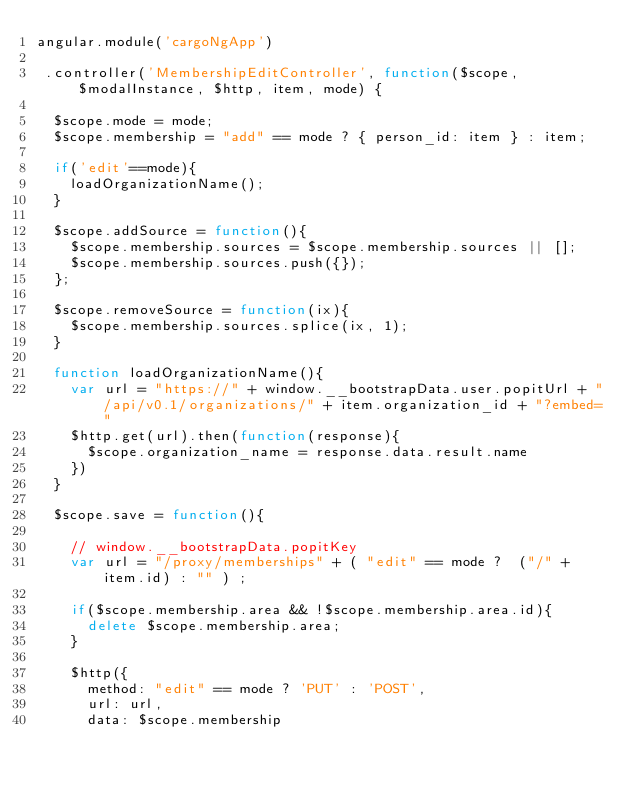Convert code to text. <code><loc_0><loc_0><loc_500><loc_500><_JavaScript_>angular.module('cargoNgApp')

 .controller('MembershipEditController', function($scope, $modalInstance, $http, item, mode) {

 	$scope.mode = mode;
 	$scope.membership = "add" == mode ? { person_id: item } : item;

 	if('edit'==mode){
 		loadOrganizationName();
 	}

 	$scope.addSource = function(){
 		$scope.membership.sources = $scope.membership.sources || []; 
 		$scope.membership.sources.push({});
 	};

 	$scope.removeSource = function(ix){
 		$scope.membership.sources.splice(ix, 1);
 	}

 	function loadOrganizationName(){
	 	var url = "https://" + window.__bootstrapData.user.popitUrl + "/api/v0.1/organizations/" + item.organization_id + "?embed="
	 	$http.get(url).then(function(response){
	 		$scope.organization_name = response.data.result.name
	 	})
 	}

 	$scope.save = function(){

 		// window.__bootstrapData.popitKey
 		var url = "/proxy/memberships" + ( "edit" == mode ?  ("/" + item.id) : "" ) ;
 		
 		if($scope.membership.area && !$scope.membership.area.id){
 			delete $scope.membership.area;
 		}

 		$http({
 			method: "edit" == mode ? 'PUT' : 'POST',
 			url: url, 
 			data: $scope.membership</code> 